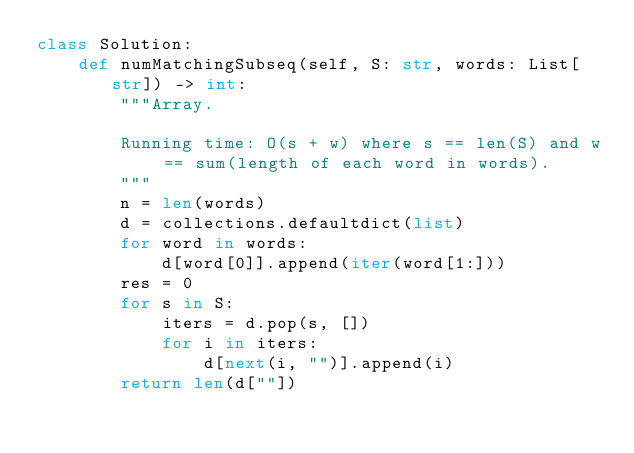Convert code to text. <code><loc_0><loc_0><loc_500><loc_500><_Python_>class Solution:
    def numMatchingSubseq(self, S: str, words: List[str]) -> int:
        """Array.

        Running time: O(s + w) where s == len(S) and w == sum(length of each word in words).
        """
        n = len(words)
        d = collections.defaultdict(list)
        for word in words:
            d[word[0]].append(iter(word[1:]))
        res = 0
        for s in S:
            iters = d.pop(s, [])
            for i in iters:
                d[next(i, "")].append(i)
        return len(d[""])
</code> 